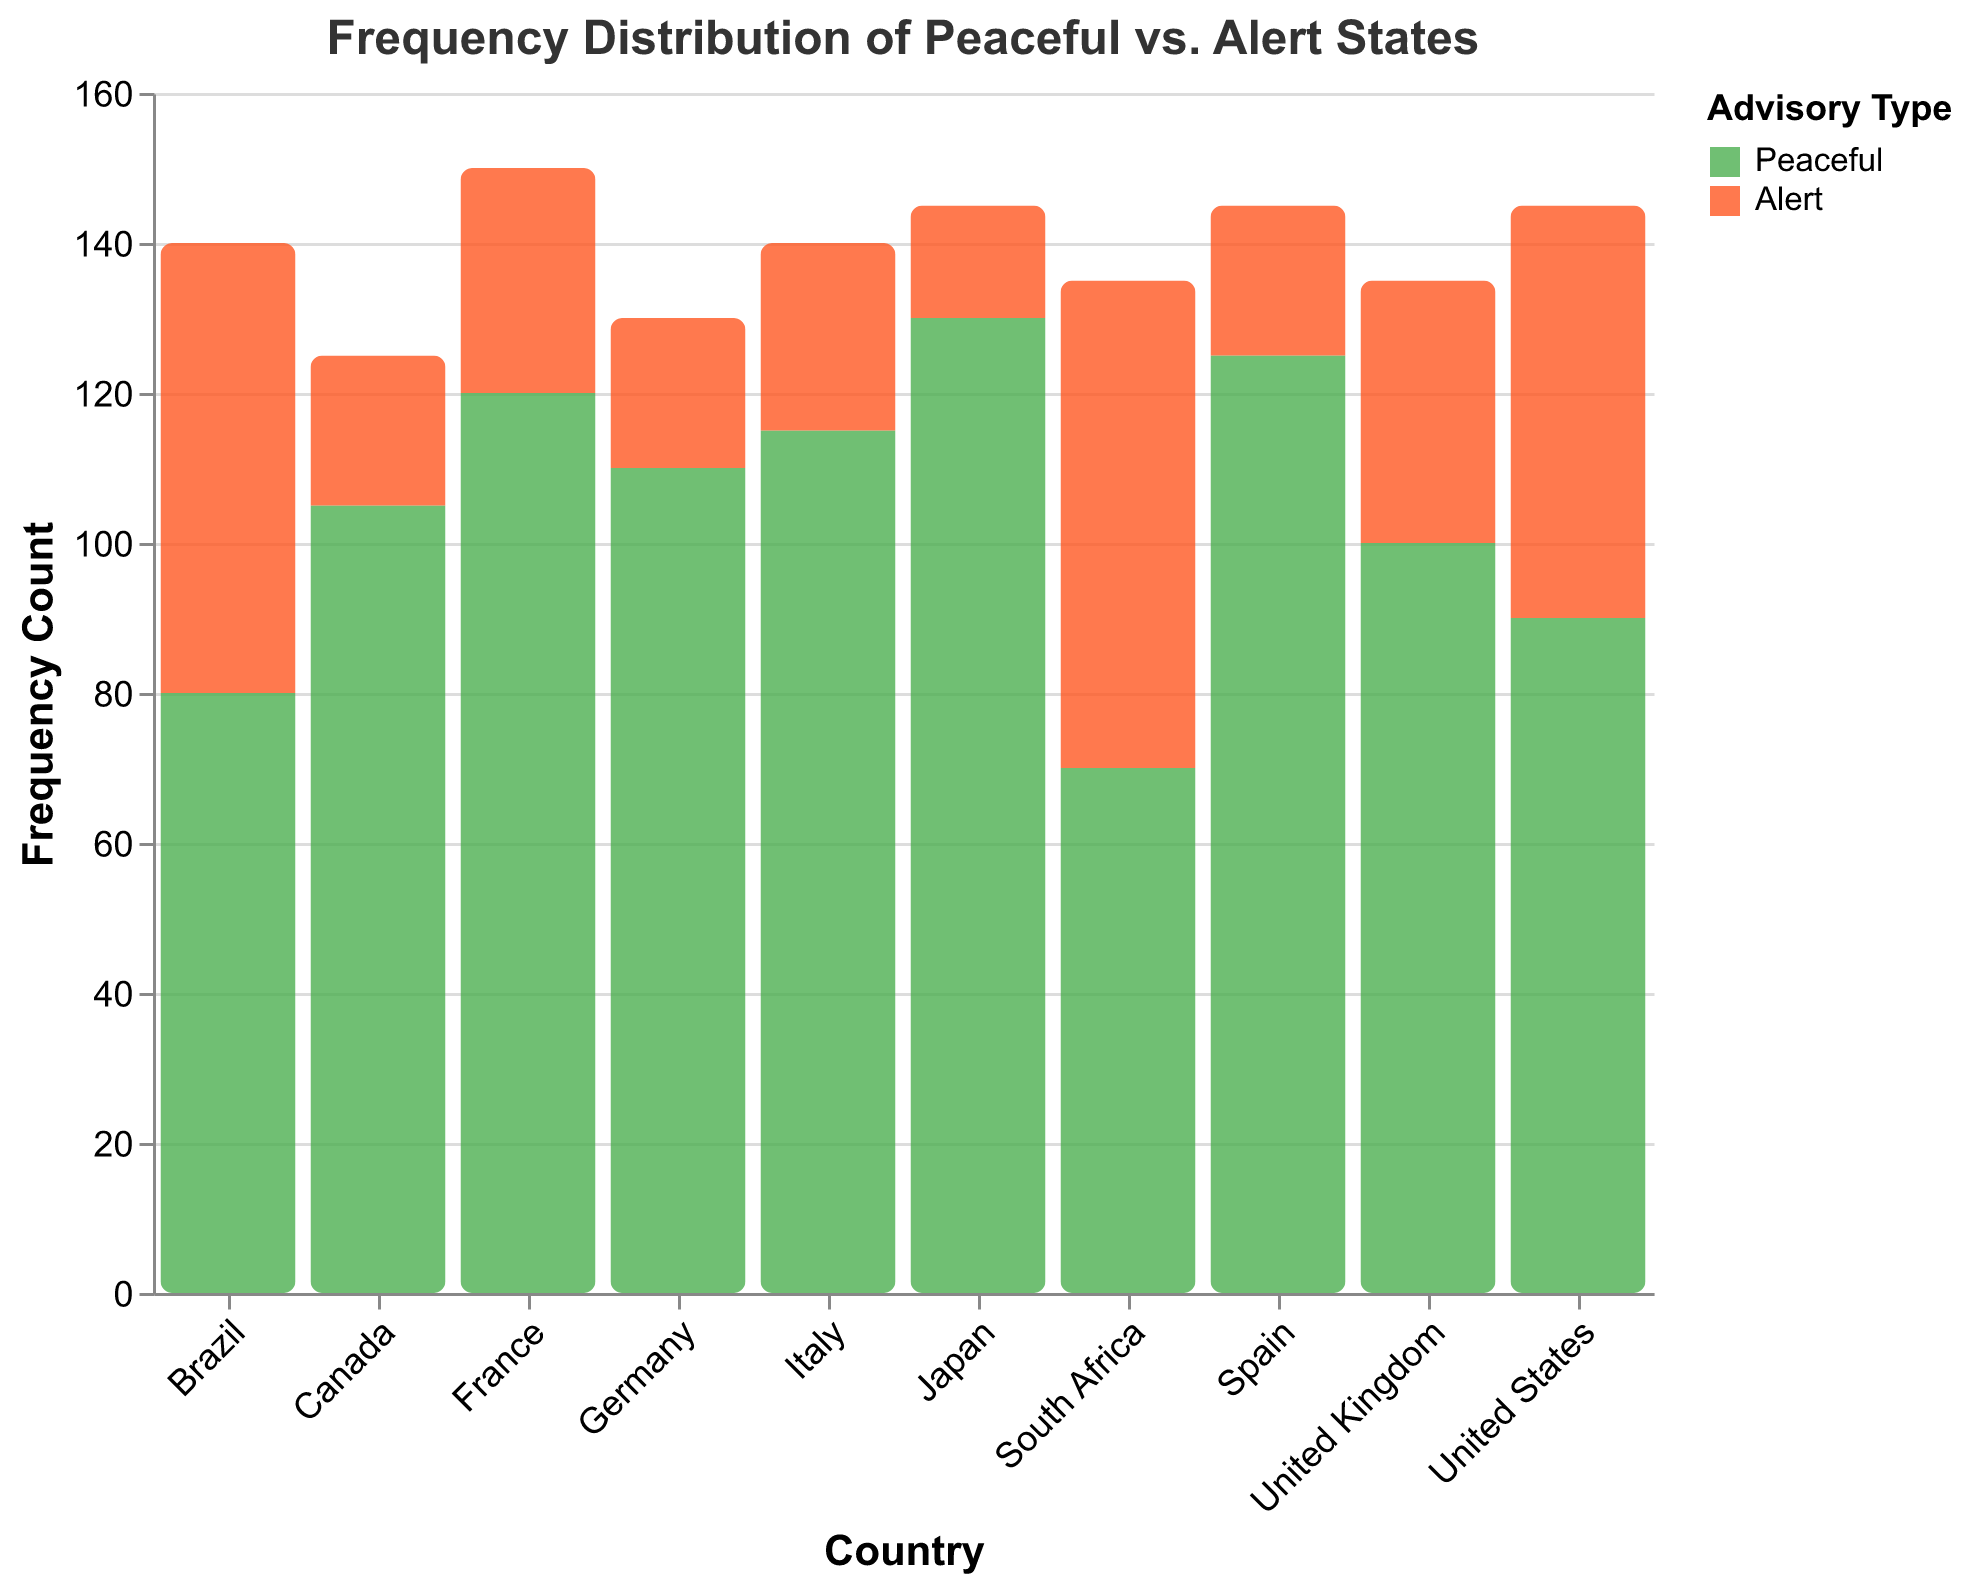How many countries are included in the figure? Count the number of unique entries under the "Country" axis. The countries listed are France, Germany, Italy, Spain, United Kingdom, Japan, Brazil, South Africa, United States, and Canada, which totals up to 10.
Answer: 10 Which country has the highest frequency count for the "Peaceful" advisory type? Look at the bar heights for each country under the "Peaceful" advisory type. Japan has the tallest bar with a frequency count of 130.
Answer: Japan What is the total frequency count of peaceful advisories across all countries? Add up the "Peaceful" frequency counts for all the countries: 120 (France) + 110 (Germany) + 115 (Italy) + 125 (Spain) + 100 (United Kingdom) + 130 (Japan) + 80 (Brazil) + 70 (South Africa) + 90 (United States) + 105 (Canada) = 1045.
Answer: 1045 Which country has the smallest difference between "Peaceful" and "Alert" advisory frequencies? Calculate the difference (Peaceful - Alert) for each country and find the smallest value: France (90), Germany (90), Italy (90), Spain (105), United Kingdom (65), Japan (115), Brazil (20), South Africa (5), United States (35), and Canada (85). The smallest difference is 5 for South Africa.
Answer: South Africa For which advisory type is the sum of frequencies higher? Compare the total frequency of the "Peaceful" and "Alert" types. "Peaceful" totals: 1045 and "Alert" totals: 365. "Peaceful" has the higher sum.
Answer: Peaceful Which two countries have the largest difference in "Alert" advisories? Compare the "Alert" frequency counts across the countries and find the largest difference: Brazil (60) and Japan (15) have a difference of 45.
Answer: Brazil and Japan What is the average frequency count of the "Alert" advisories? Sum the frequencies of "Alert" advisories and divide by the number of countries: (30 + 20 + 25 + 20 + 35 + 15 + 60 + 65 + 55 + 20) / 10 = 345 / 10 = 34.5
Answer: 34.5 Which advisory type does the United Kingdom have more frequently? Compare the bars labeled "Peaceful" and "Alert" for the United Kingdom. "Peaceful" has a count of 100, while "Alert" has 35. "Peaceful" is more frequent.
Answer: Peaceful In which country is the gap between "Peaceful" and "Alert" advisories smallest? Calculate the gaps for all countries: France (90), Germany (90), Italy (90), Spain (105), United Kingdom (65), Japan (115), Brazil (20), South Africa (5), United States (35), and Canada (85). The smallest gap is 5 for South Africa.
Answer: South Africa 